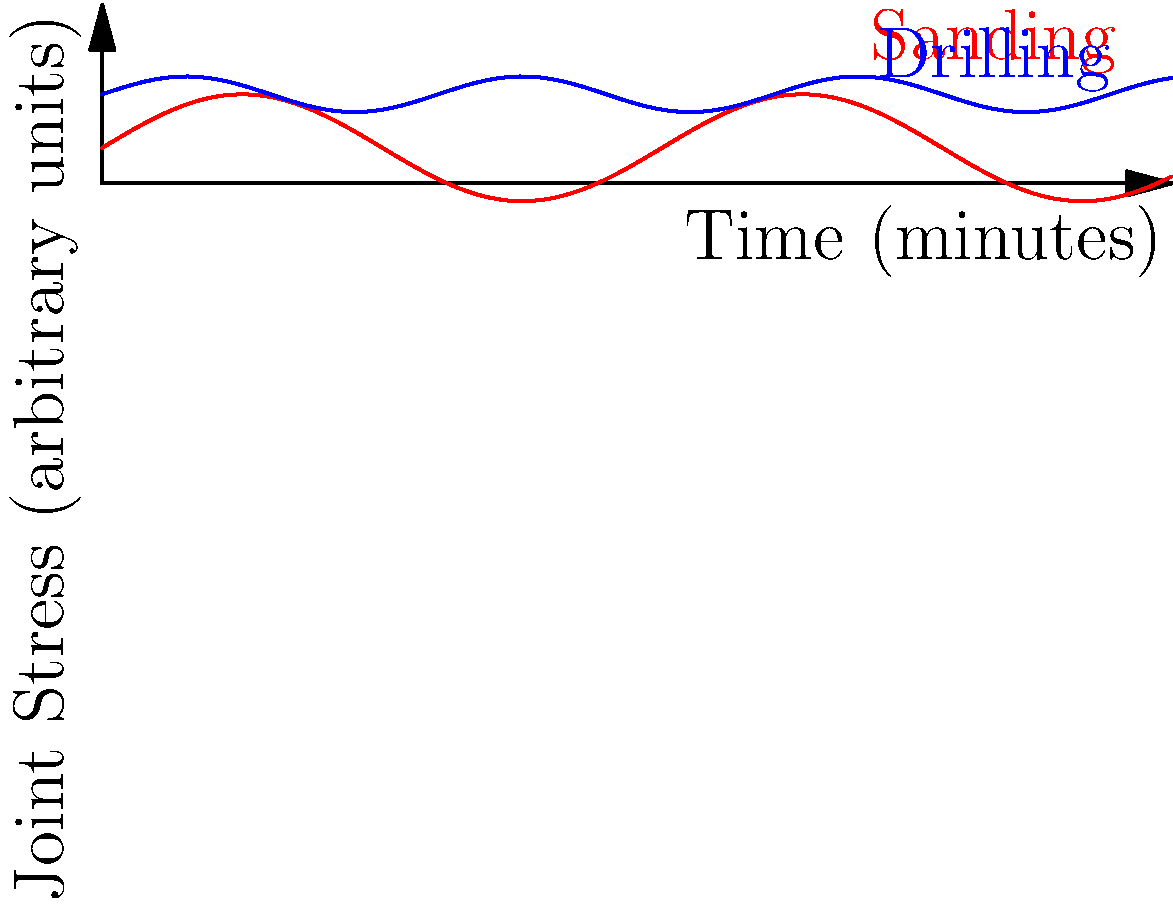The graph shows the joint stress patterns during two common DIY tasks: sanding and drilling. Based on the biomechanical stress patterns shown, which activity is likely to have a greater long-term impact on joint health, and why? To determine which activity has a greater long-term impact on joint health, we need to analyze the stress patterns shown in the graph:

1. Sanding (red curve):
   - Shows a cyclical pattern with higher amplitude
   - Stress levels vary between approximately 2 and 5 units
   - Frequency of stress cycles is higher (more peaks and troughs)

2. Drilling (blue curve):
   - Shows a more consistent stress level with smaller variations
   - Stress levels remain mostly between 4 and 6 units
   - Frequency of stress cycles is lower

3. Impact on joint health:
   - Repetitive stress with high amplitude (as in sanding) can lead to greater wear and tear on joints
   - The frequent changes in stress direction during sanding can cause more fatigue in joint tissues
   - Constant moderate stress (as in drilling) may allow for better adaptation of joint tissues

4. Long-term effects:
   - Sanding's high-frequency, high-amplitude stress pattern is more likely to cause cumulative damage over time
   - Drilling's more consistent stress pattern may be less damaging, allowing for better recovery between stress cycles

Therefore, based on the biomechanical stress patterns shown, sanding is likely to have a greater long-term impact on joint health due to its higher amplitude and frequency of stress cycles, which can lead to increased wear and tear on joint tissues over time.
Answer: Sanding, due to higher amplitude and frequency of stress cycles. 